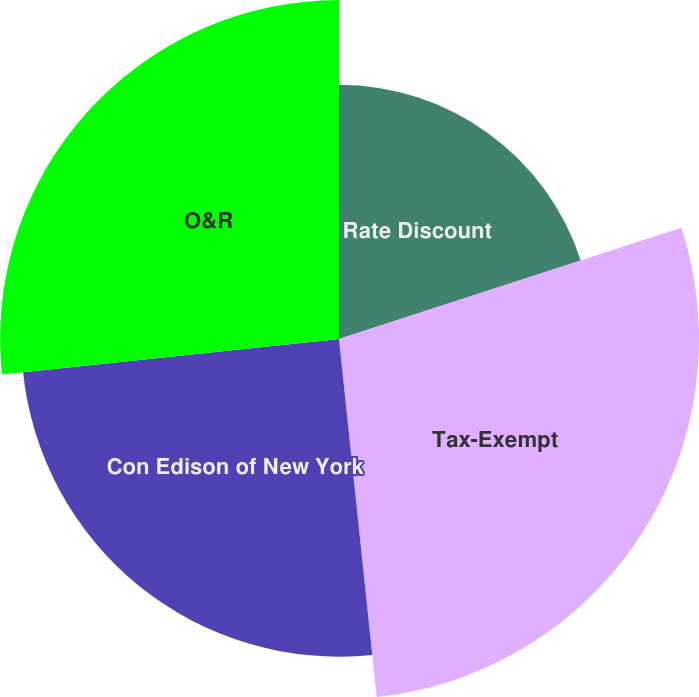Convert chart to OTSL. <chart><loc_0><loc_0><loc_500><loc_500><pie_chart><fcel>Rate Discount<fcel>Tax-Exempt<fcel>Con Edison of New York<fcel>O&R<nl><fcel>20.0%<fcel>28.33%<fcel>25.0%<fcel>26.67%<nl></chart> 